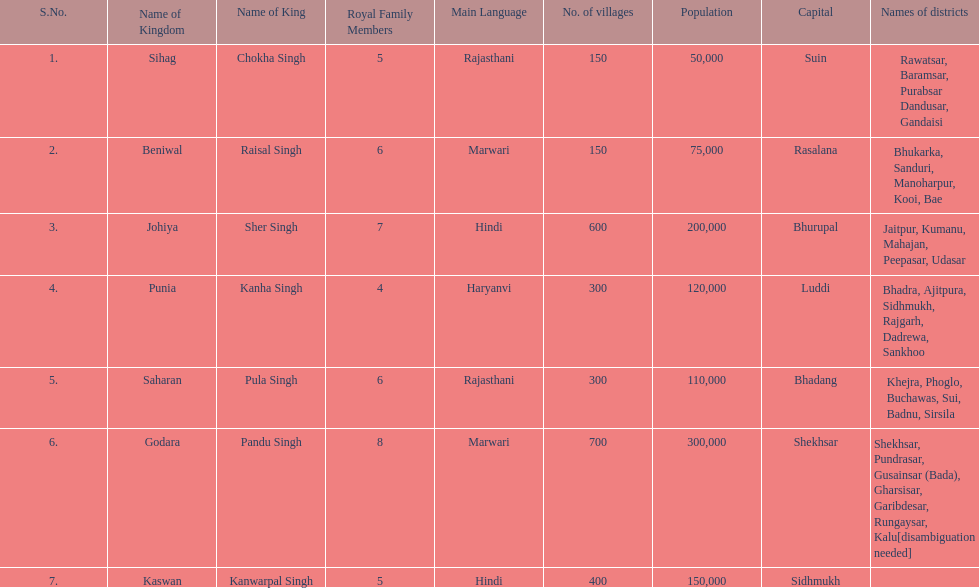Could you parse the entire table as a dict? {'header': ['S.No.', 'Name of Kingdom', 'Name of King', 'Royal Family Members', 'Main Language', 'No. of villages', 'Population', 'Capital', 'Names of districts'], 'rows': [['1.', 'Sihag', 'Chokha Singh', '5', 'Rajasthani', '150', '50,000', 'Suin', 'Rawatsar, Baramsar, Purabsar Dandusar, Gandaisi'], ['2.', 'Beniwal', 'Raisal Singh', '6', 'Marwari', '150', '75,000', 'Rasalana', 'Bhukarka, Sanduri, Manoharpur, Kooi, Bae'], ['3.', 'Johiya', 'Sher Singh', '7', 'Hindi', '600', '200,000', 'Bhurupal', 'Jaitpur, Kumanu, Mahajan, Peepasar, Udasar'], ['4.', 'Punia', 'Kanha Singh', '4', 'Haryanvi', '300', '120,000', 'Luddi', 'Bhadra, Ajitpura, Sidhmukh, Rajgarh, Dadrewa, Sankhoo'], ['5.', 'Saharan', 'Pula Singh', '6', 'Rajasthani', '300', '110,000', 'Bhadang', 'Khejra, Phoglo, Buchawas, Sui, Badnu, Sirsila'], ['6.', 'Godara', 'Pandu Singh', '8', 'Marwari', '700', '300,000', 'Shekhsar', 'Shekhsar, Pundrasar, Gusainsar (Bada), Gharsisar, Garibdesar, Rungaysar, Kalu[disambiguation needed]'], ['7.', 'Kaswan', 'Kanwarpal Singh', '5', 'Hindi', '400', '150,000', 'Sidhmukh', '']]} How many kingdoms are listed? 7. 